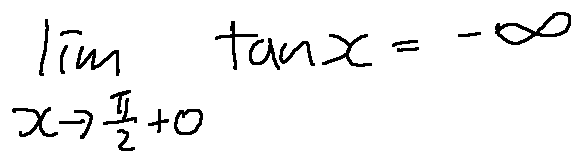Convert formula to latex. <formula><loc_0><loc_0><loc_500><loc_500>\lim \lim i t s _ { x \rightarrow \frac { \pi } { 2 } + 0 } \tan x = - \infty</formula> 